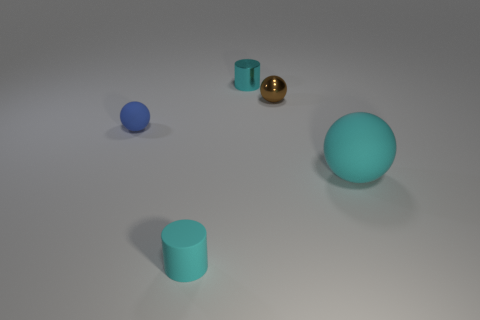What is the size of the blue object that is the same shape as the brown metal object?
Give a very brief answer. Small. What color is the small rubber thing that is the same shape as the cyan shiny object?
Offer a terse response. Cyan. There is a ball that is behind the big cyan thing and on the right side of the metal cylinder; how big is it?
Offer a very short reply. Small. What number of tiny brown metallic balls are to the left of the cyan cylinder behind the tiny cyan cylinder that is in front of the big matte thing?
Your answer should be compact. 0. What number of tiny objects are either red objects or rubber cylinders?
Your response must be concise. 1. Does the tiny cyan cylinder that is in front of the brown object have the same material as the brown object?
Your answer should be very brief. No. What is the cyan cylinder that is behind the cyan rubber object that is behind the cylinder in front of the cyan shiny thing made of?
Your response must be concise. Metal. Is there any other thing that has the same size as the cyan ball?
Your answer should be compact. No. What number of metallic things are either blue objects or small brown things?
Make the answer very short. 1. Are there any large red rubber objects?
Your answer should be compact. No. 